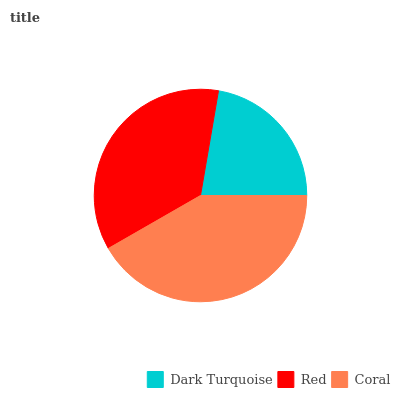Is Dark Turquoise the minimum?
Answer yes or no. Yes. Is Coral the maximum?
Answer yes or no. Yes. Is Red the minimum?
Answer yes or no. No. Is Red the maximum?
Answer yes or no. No. Is Red greater than Dark Turquoise?
Answer yes or no. Yes. Is Dark Turquoise less than Red?
Answer yes or no. Yes. Is Dark Turquoise greater than Red?
Answer yes or no. No. Is Red less than Dark Turquoise?
Answer yes or no. No. Is Red the high median?
Answer yes or no. Yes. Is Red the low median?
Answer yes or no. Yes. Is Dark Turquoise the high median?
Answer yes or no. No. Is Dark Turquoise the low median?
Answer yes or no. No. 